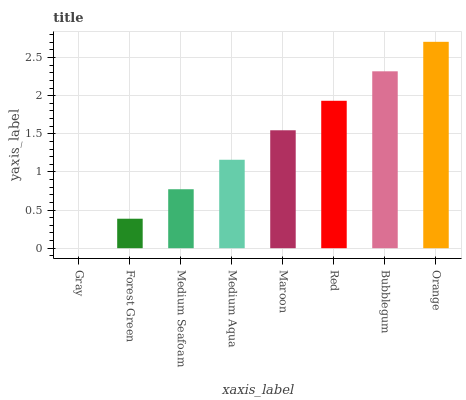Is Orange the maximum?
Answer yes or no. Yes. Is Forest Green the minimum?
Answer yes or no. No. Is Forest Green the maximum?
Answer yes or no. No. Is Forest Green greater than Gray?
Answer yes or no. Yes. Is Gray less than Forest Green?
Answer yes or no. Yes. Is Gray greater than Forest Green?
Answer yes or no. No. Is Forest Green less than Gray?
Answer yes or no. No. Is Maroon the high median?
Answer yes or no. Yes. Is Medium Aqua the low median?
Answer yes or no. Yes. Is Medium Aqua the high median?
Answer yes or no. No. Is Bubblegum the low median?
Answer yes or no. No. 